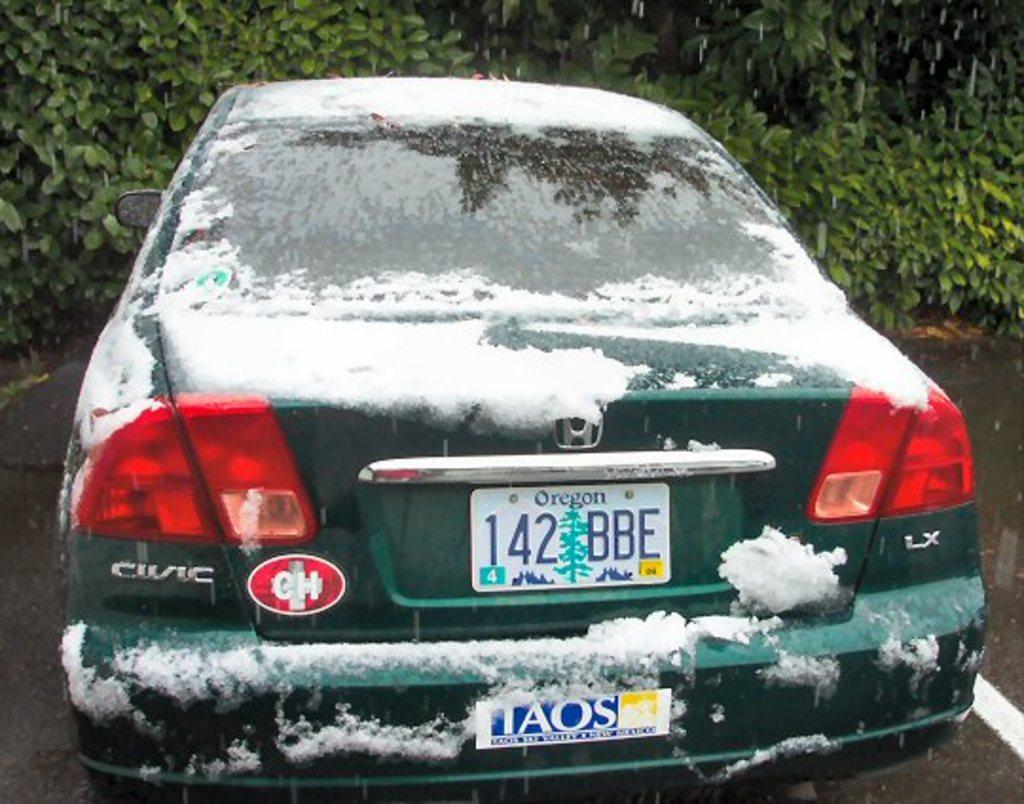<image>
Offer a succinct explanation of the picture presented. A snow covered green Honda Civic with an Oregon license plate. 